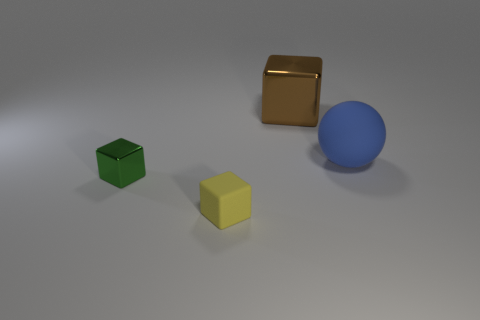Subtract all shiny blocks. How many blocks are left? 1 Add 2 big purple spheres. How many objects exist? 6 Subtract 1 blocks. How many blocks are left? 2 Subtract all brown cubes. How many cubes are left? 2 Subtract all blocks. How many objects are left? 1 Subtract 0 red balls. How many objects are left? 4 Subtract all yellow cubes. Subtract all brown cylinders. How many cubes are left? 2 Subtract all small purple shiny cubes. Subtract all brown shiny blocks. How many objects are left? 3 Add 2 big matte balls. How many big matte balls are left? 3 Add 2 balls. How many balls exist? 3 